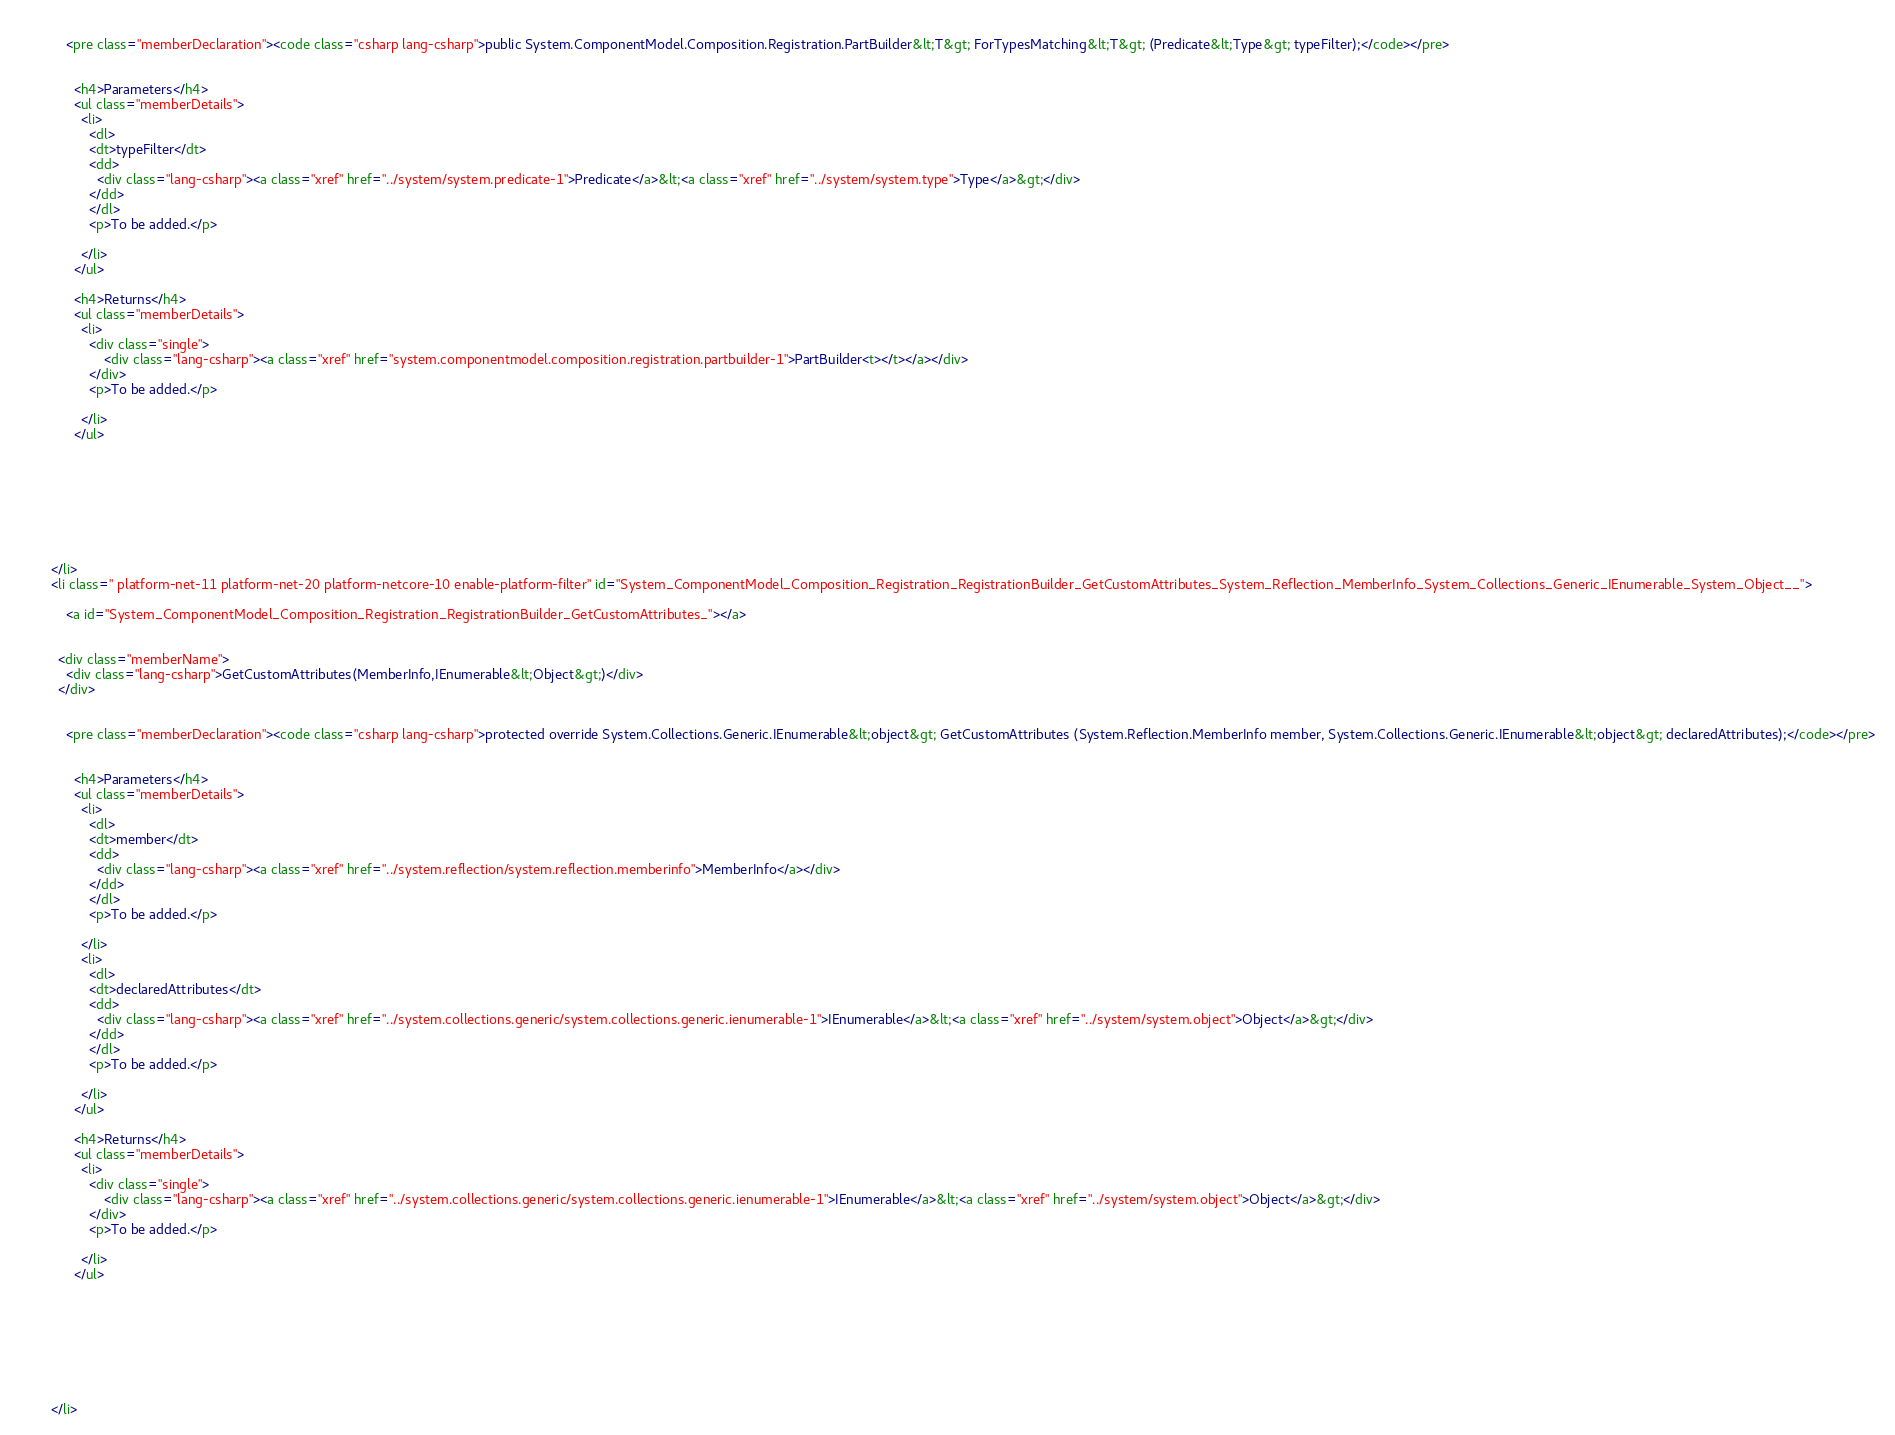Convert code to text. <code><loc_0><loc_0><loc_500><loc_500><_HTML_>    
            <pre class="memberDeclaration"><code class="csharp lang-csharp">public System.ComponentModel.Composition.Registration.PartBuilder&lt;T&gt; ForTypesMatching&lt;T&gt; (Predicate&lt;Type&gt; typeFilter);</code></pre>
    
    
              <h4>Parameters</h4>
              <ul class="memberDetails">
                <li>
                  <dl>
                  <dt>typeFilter</dt>
                  <dd>
                    <div class="lang-csharp"><a class="xref" href="../system/system.predicate-1">Predicate</a>&lt;<a class="xref" href="../system/system.type">Type</a>&gt;</div>
                  </dd>
                  </dl>
                  <p>To be added.</p>

                </li>
              </ul>
    
              <h4>Returns</h4>
              <ul class="memberDetails">
                <li>
                  <div class="single">                
                      <div class="lang-csharp"><a class="xref" href="system.componentmodel.composition.registration.partbuilder-1">PartBuilder<t></t></a></div>
                  </div>
                  <p>To be added.</p>

                </li>
              </ul>
    
    
    
          
    
    
    
    
        </li>
        <li class=" platform-net-11 platform-net-20 platform-netcore-10 enable-platform-filter" id="System_ComponentModel_Composition_Registration_RegistrationBuilder_GetCustomAttributes_System_Reflection_MemberInfo_System_Collections_Generic_IEnumerable_System_Object__">
    
            <a id="System_ComponentModel_Composition_Registration_RegistrationBuilder_GetCustomAttributes_"></a>
    
    
          <div class="memberName">
            <div class="lang-csharp">GetCustomAttributes(MemberInfo,IEnumerable&lt;Object&gt;)</div>        
          </div>
    
    
            <pre class="memberDeclaration"><code class="csharp lang-csharp">protected override System.Collections.Generic.IEnumerable&lt;object&gt; GetCustomAttributes (System.Reflection.MemberInfo member, System.Collections.Generic.IEnumerable&lt;object&gt; declaredAttributes);</code></pre>
    
    
              <h4>Parameters</h4>
              <ul class="memberDetails">
                <li>
                  <dl>
                  <dt>member</dt>
                  <dd>
                    <div class="lang-csharp"><a class="xref" href="../system.reflection/system.reflection.memberinfo">MemberInfo</a></div>
                  </dd>
                  </dl>
                  <p>To be added.</p>

                </li>
                <li>
                  <dl>
                  <dt>declaredAttributes</dt>
                  <dd>
                    <div class="lang-csharp"><a class="xref" href="../system.collections.generic/system.collections.generic.ienumerable-1">IEnumerable</a>&lt;<a class="xref" href="../system/system.object">Object</a>&gt;</div>
                  </dd>
                  </dl>
                  <p>To be added.</p>

                </li>
              </ul>
    
              <h4>Returns</h4>
              <ul class="memberDetails">
                <li>
                  <div class="single">                
                      <div class="lang-csharp"><a class="xref" href="../system.collections.generic/system.collections.generic.ienumerable-1">IEnumerable</a>&lt;<a class="xref" href="../system/system.object">Object</a>&gt;</div>
                  </div>
                  <p>To be added.</p>

                </li>
              </ul>
    
    
    
          
    
    
    
    
        </li></code> 